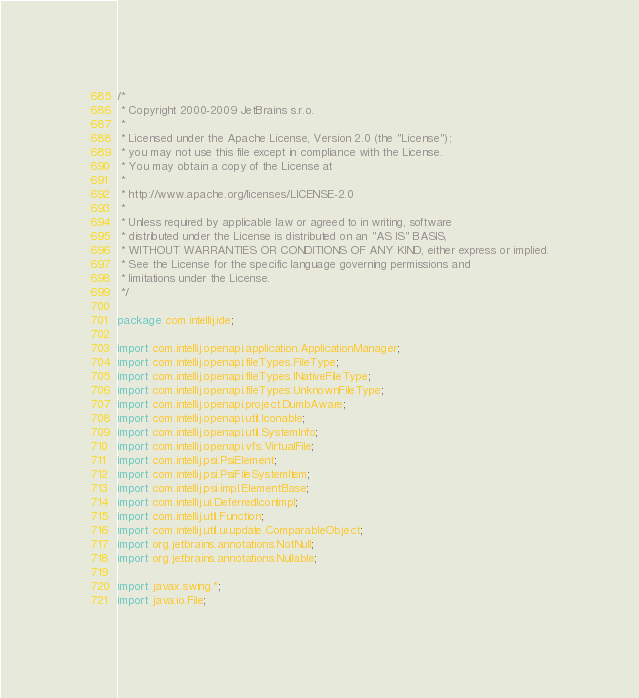<code> <loc_0><loc_0><loc_500><loc_500><_Java_>/*
 * Copyright 2000-2009 JetBrains s.r.o.
 *
 * Licensed under the Apache License, Version 2.0 (the "License");
 * you may not use this file except in compliance with the License.
 * You may obtain a copy of the License at
 *
 * http://www.apache.org/licenses/LICENSE-2.0
 *
 * Unless required by applicable law or agreed to in writing, software
 * distributed under the License is distributed on an "AS IS" BASIS,
 * WITHOUT WARRANTIES OR CONDITIONS OF ANY KIND, either express or implied.
 * See the License for the specific language governing permissions and
 * limitations under the License.
 */

package com.intellij.ide;

import com.intellij.openapi.application.ApplicationManager;
import com.intellij.openapi.fileTypes.FileType;
import com.intellij.openapi.fileTypes.INativeFileType;
import com.intellij.openapi.fileTypes.UnknownFileType;
import com.intellij.openapi.project.DumbAware;
import com.intellij.openapi.util.Iconable;
import com.intellij.openapi.util.SystemInfo;
import com.intellij.openapi.vfs.VirtualFile;
import com.intellij.psi.PsiElement;
import com.intellij.psi.PsiFileSystemItem;
import com.intellij.psi.impl.ElementBase;
import com.intellij.ui.DeferredIconImpl;
import com.intellij.util.Function;
import com.intellij.util.ui.update.ComparableObject;
import org.jetbrains.annotations.NotNull;
import org.jetbrains.annotations.Nullable;

import javax.swing.*;
import java.io.File;</code> 